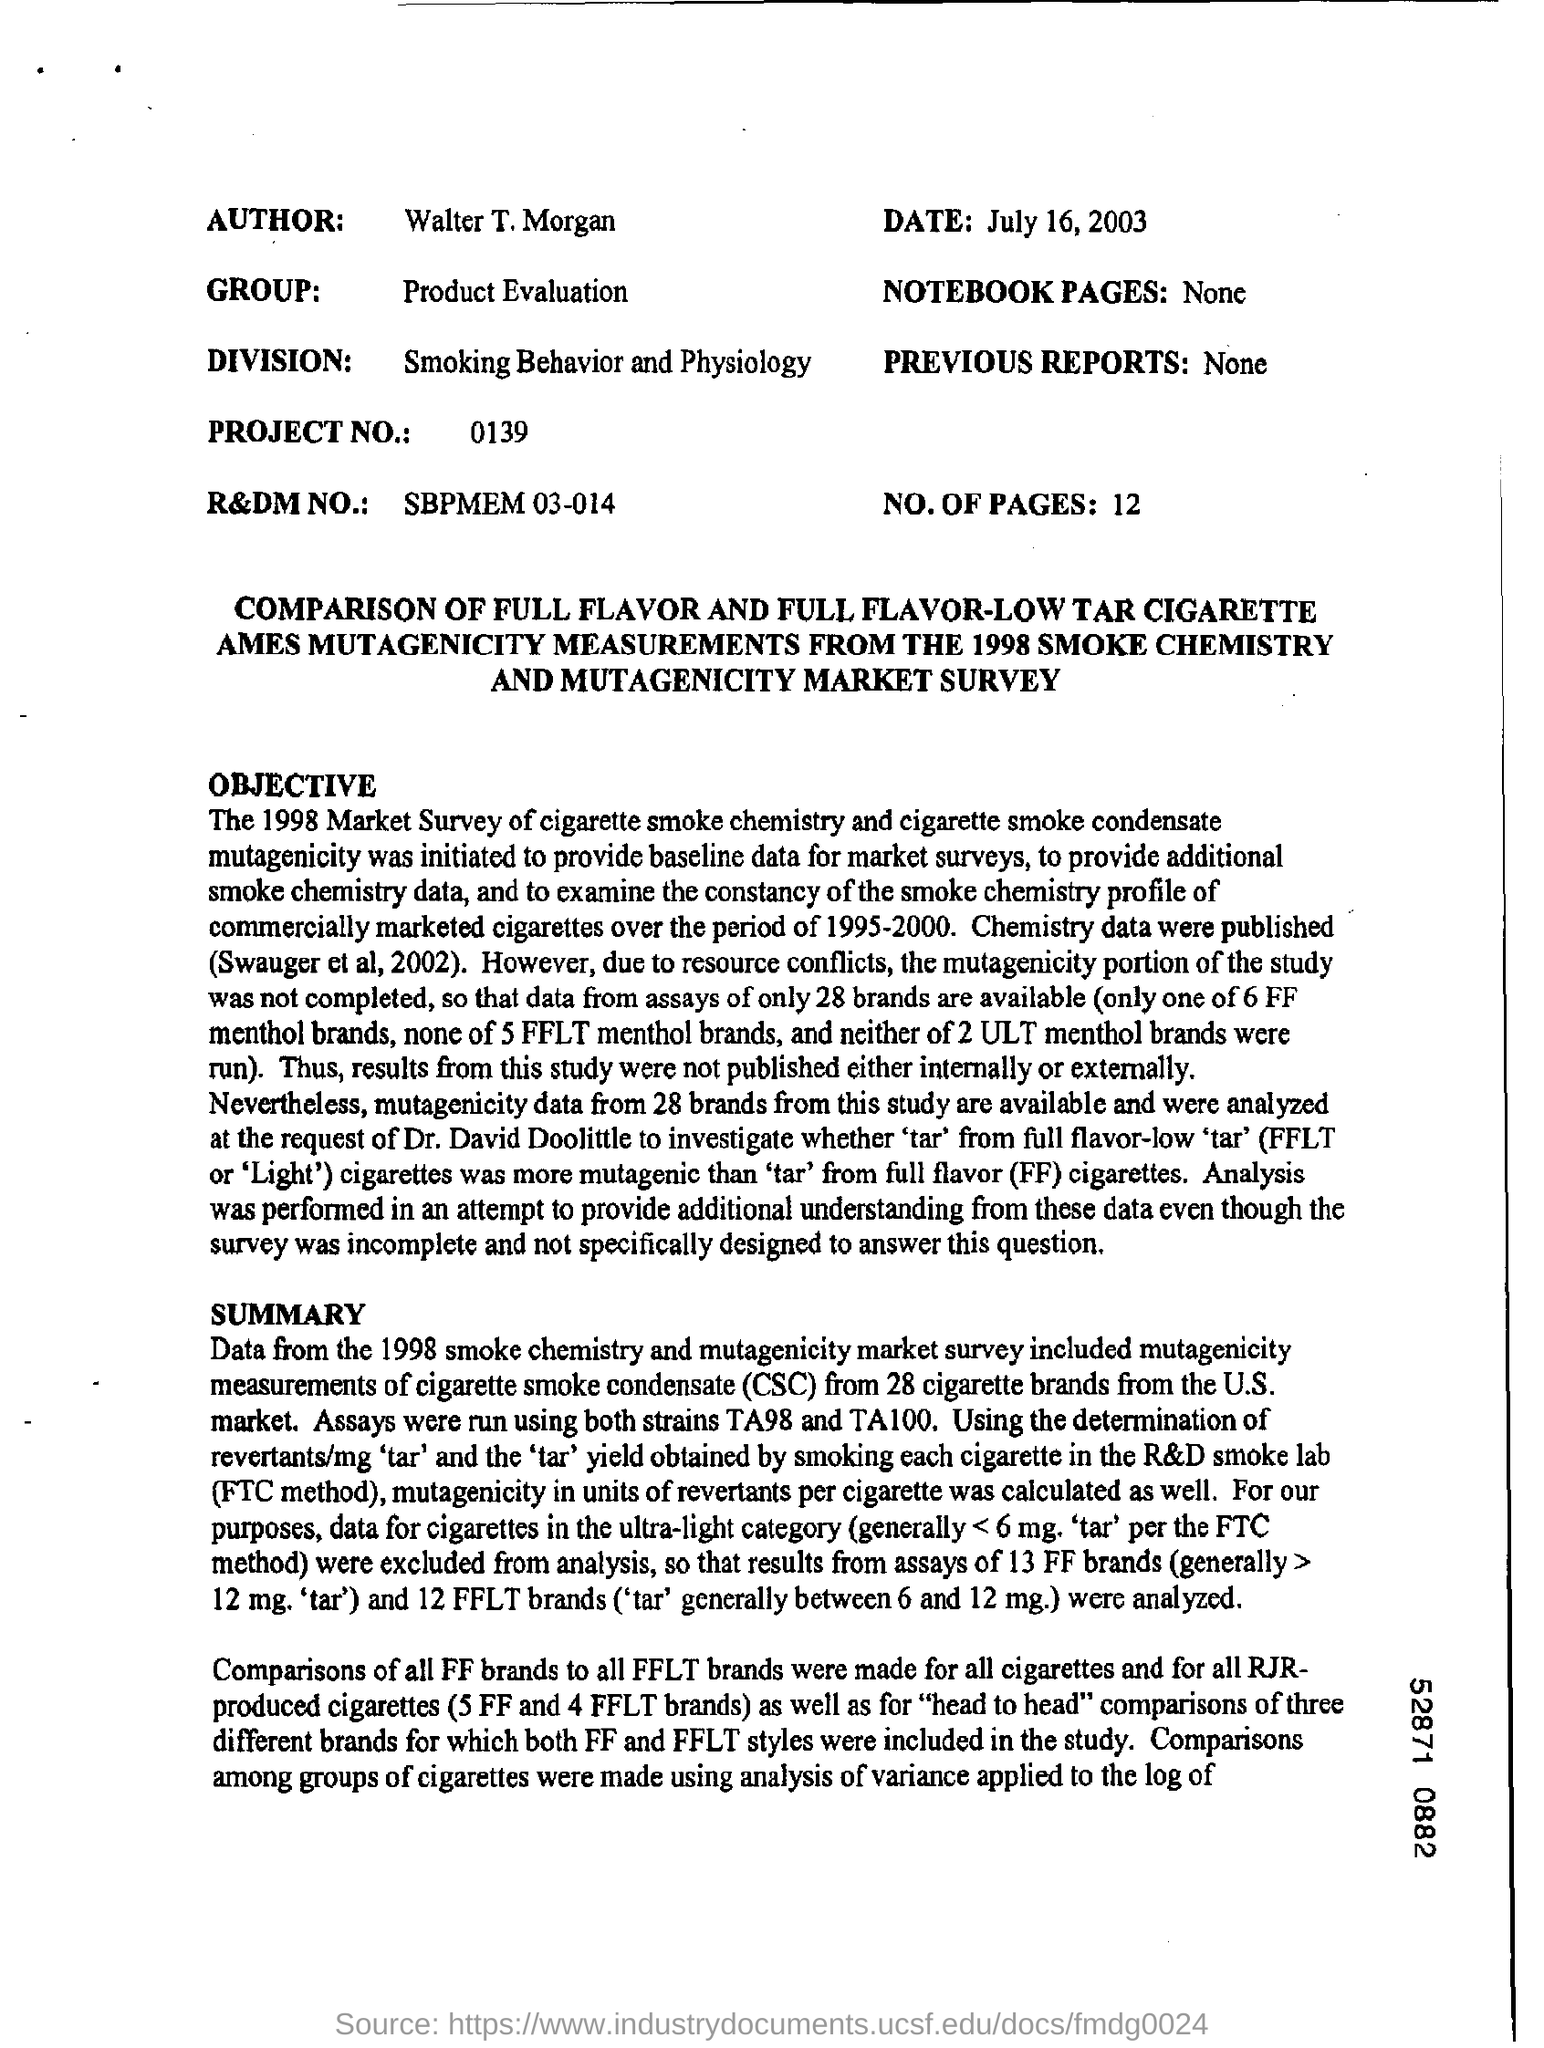Who is the author?
Offer a very short reply. Walter T. Morgan. What is the project number?
Your answer should be compact. 0139. How many number of pages are mentioned?
Provide a succinct answer. 12. When is the sheet dated?
Provide a short and direct response. July 16, 2003. Which group is mentioned?
Your answer should be compact. Product evaluation. 